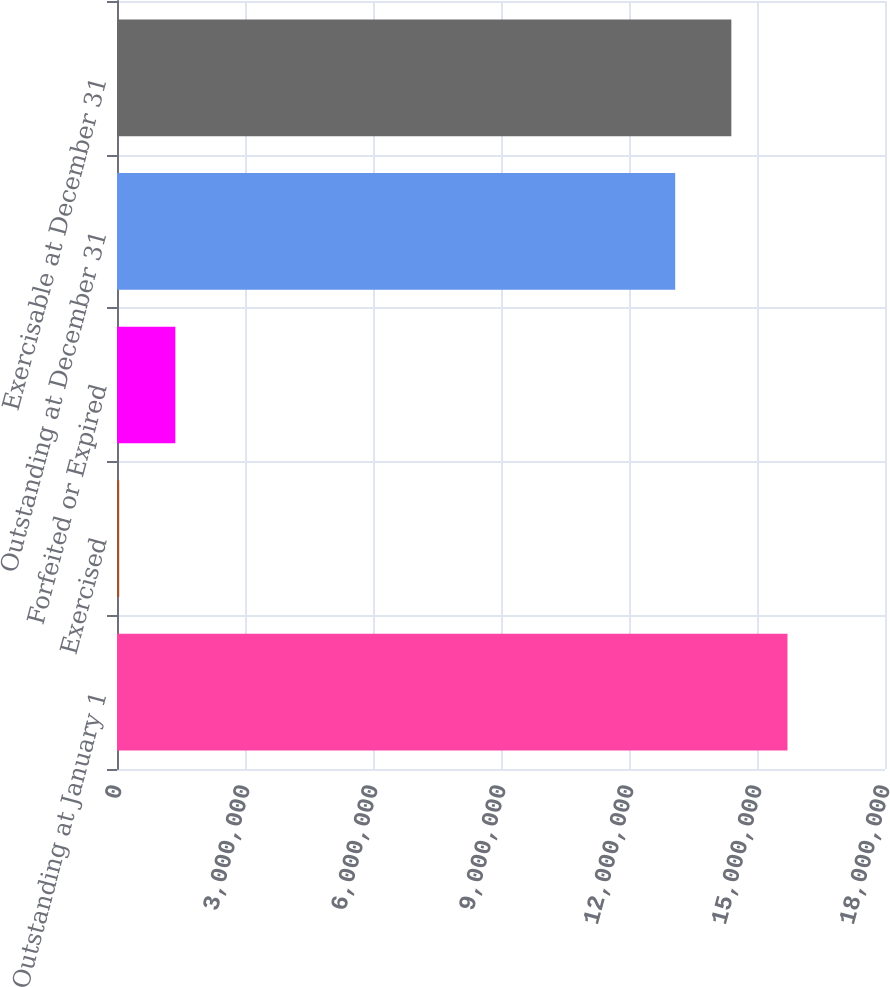Convert chart. <chart><loc_0><loc_0><loc_500><loc_500><bar_chart><fcel>Outstanding at January 1<fcel>Exercised<fcel>Forfeited or Expired<fcel>Outstanding at December 31<fcel>Exercisable at December 31<nl><fcel>1.57142e+07<fcel>51751<fcel>1.36741e+06<fcel>1.30829e+07<fcel>1.43986e+07<nl></chart> 